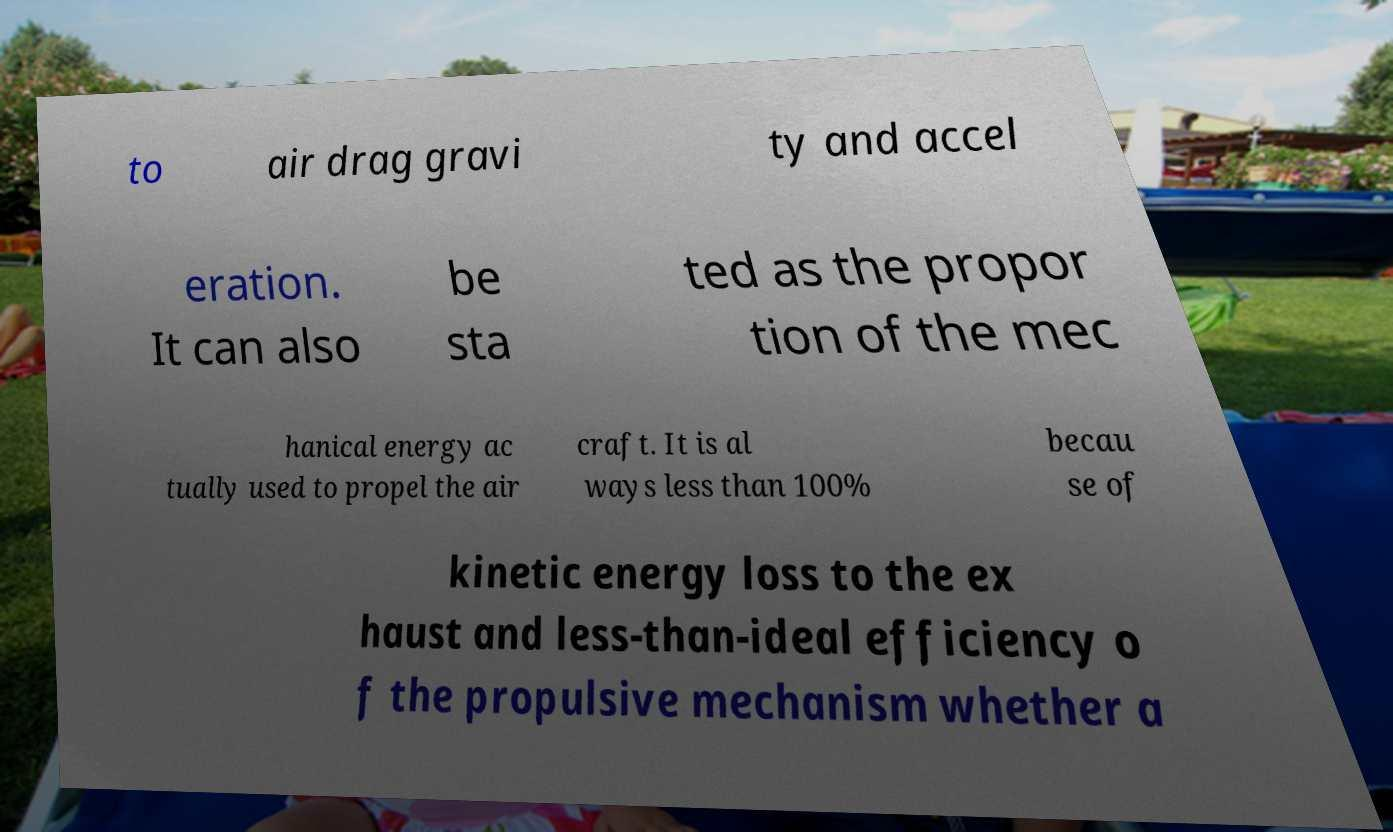What messages or text are displayed in this image? I need them in a readable, typed format. to air drag gravi ty and accel eration. It can also be sta ted as the propor tion of the mec hanical energy ac tually used to propel the air craft. It is al ways less than 100% becau se of kinetic energy loss to the ex haust and less-than-ideal efficiency o f the propulsive mechanism whether a 